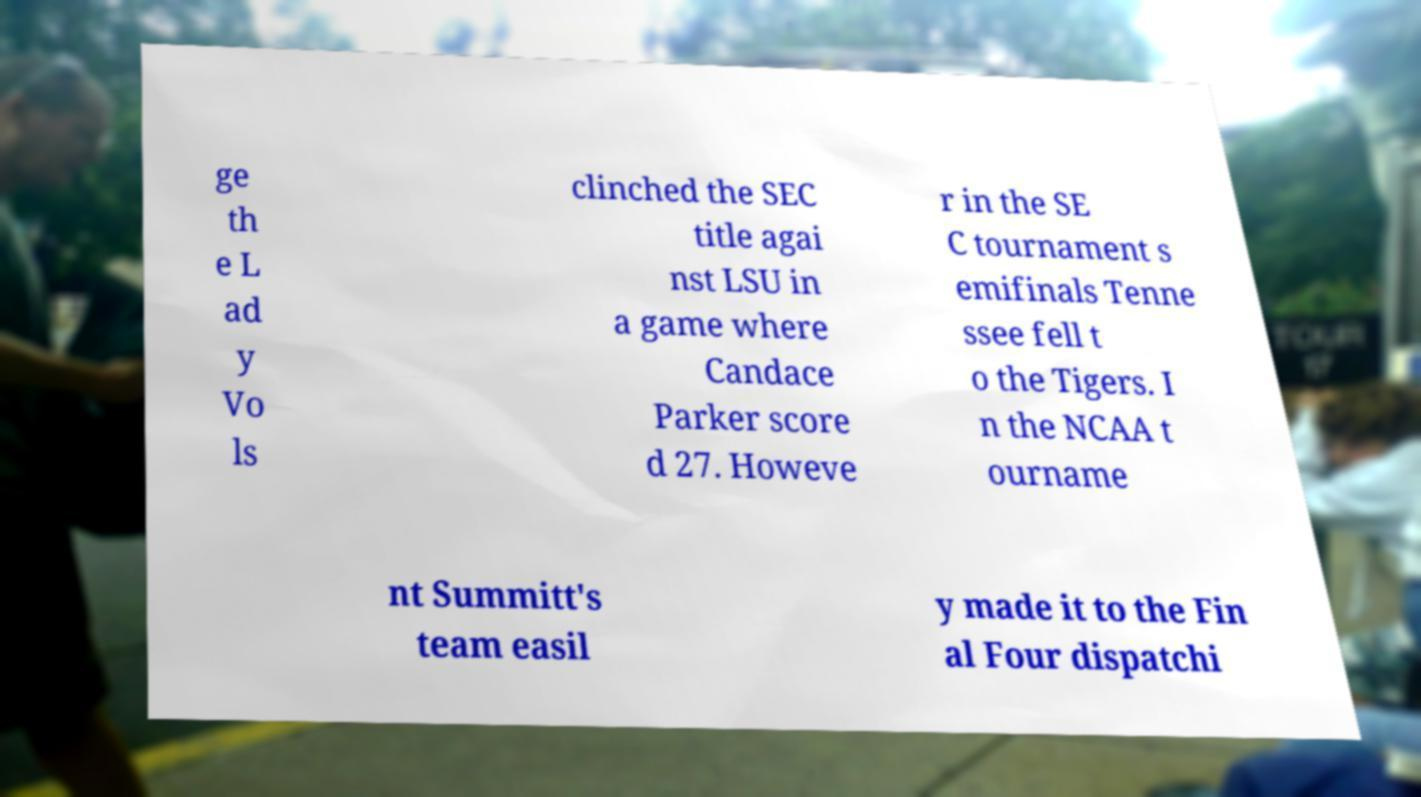Can you read and provide the text displayed in the image?This photo seems to have some interesting text. Can you extract and type it out for me? ge th e L ad y Vo ls clinched the SEC title agai nst LSU in a game where Candace Parker score d 27. Howeve r in the SE C tournament s emifinals Tenne ssee fell t o the Tigers. I n the NCAA t ourname nt Summitt's team easil y made it to the Fin al Four dispatchi 